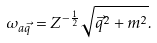Convert formula to latex. <formula><loc_0><loc_0><loc_500><loc_500>\omega _ { a \vec { q } } = Z ^ { - \frac { 1 } { 2 } } \sqrt { \vec { q } ^ { 2 } + m ^ { 2 } } .</formula> 